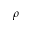<formula> <loc_0><loc_0><loc_500><loc_500>\rho</formula> 